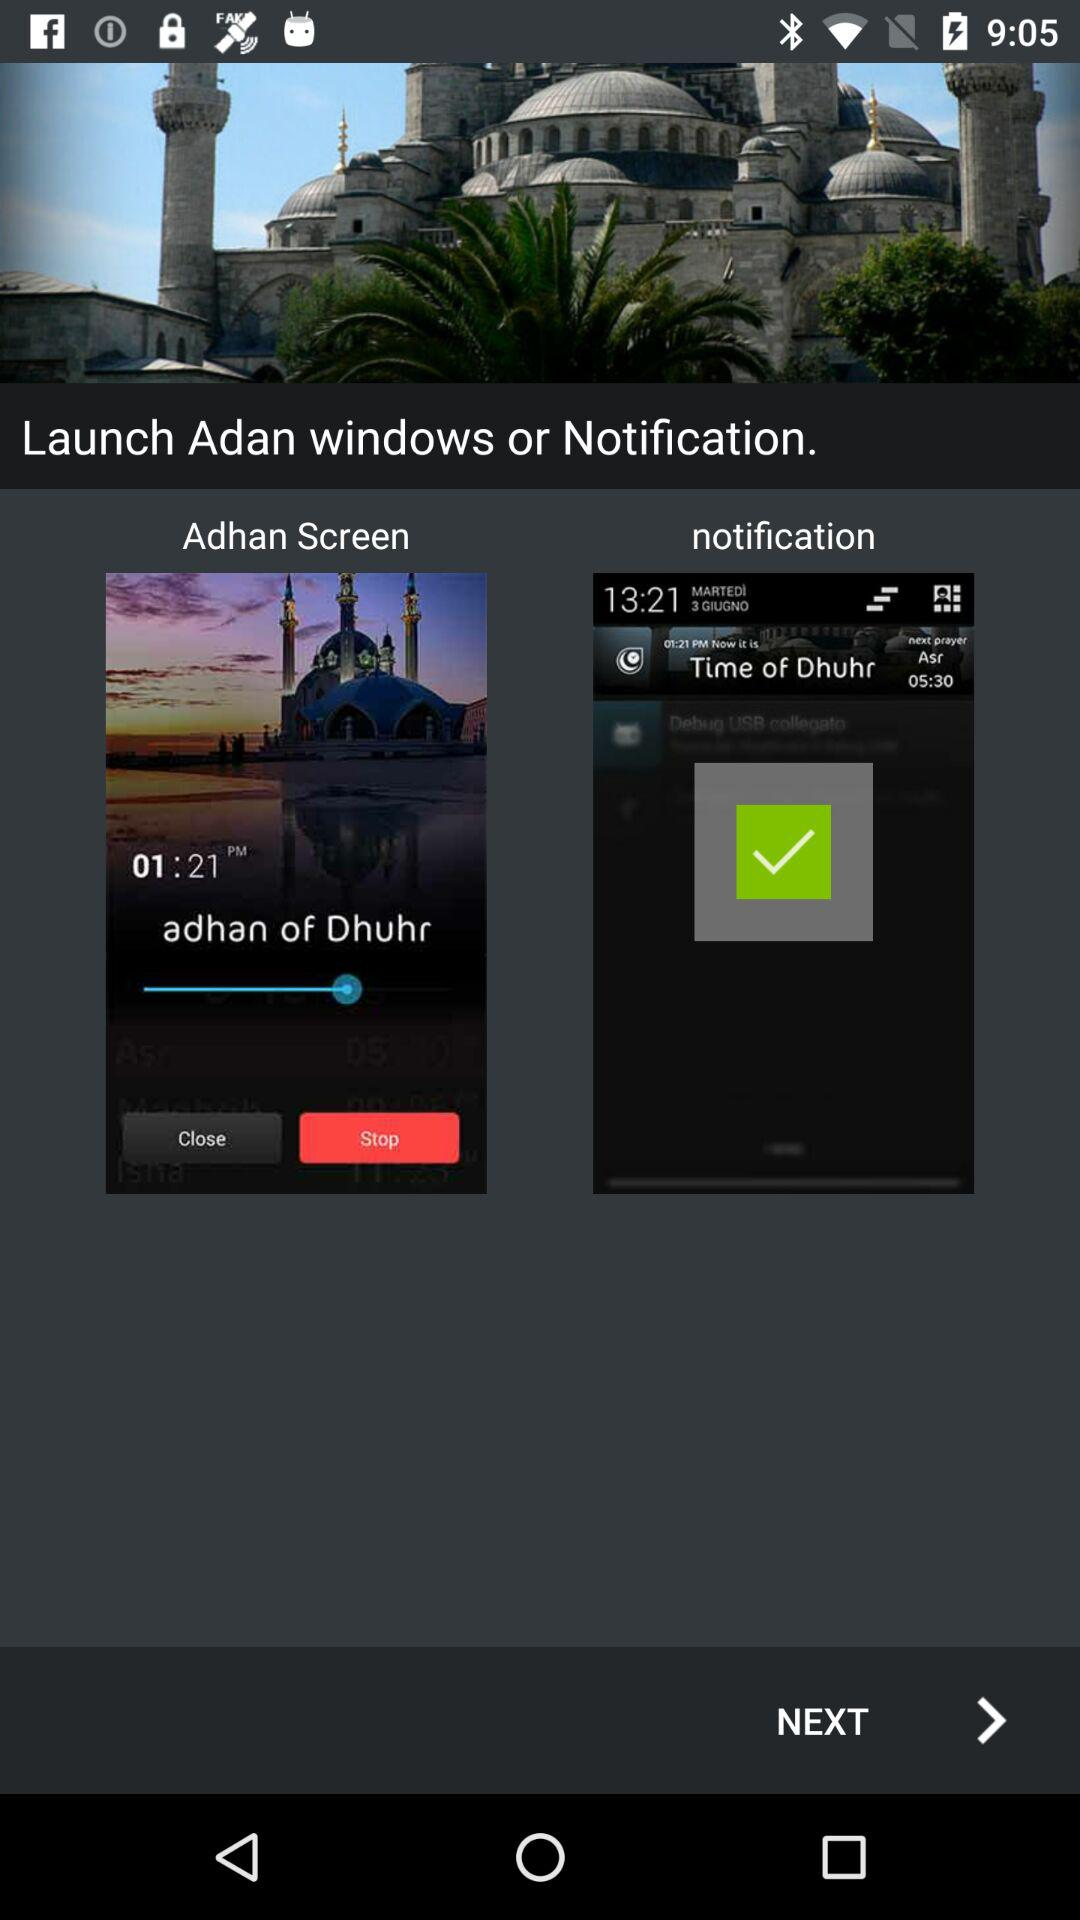Which option is selected? The selected option is "notification". 